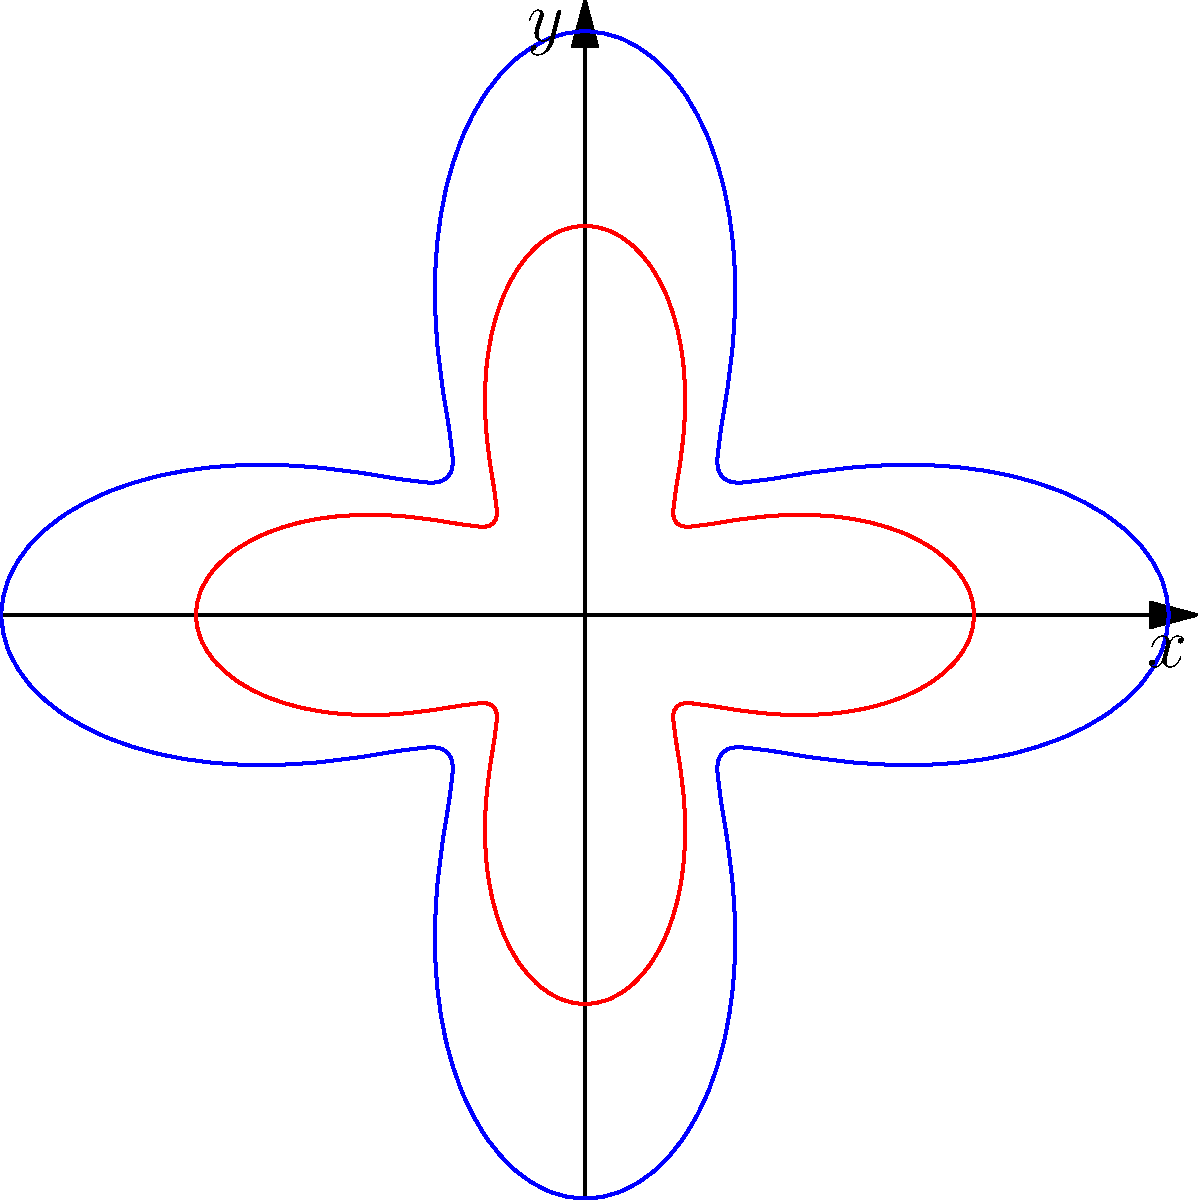The polar curve $r = 2 + \cos(4\theta)$ represents a simplified flower motif common in Vietnamese textiles. If this motif is scaled by a factor of 1.5, what is the new polar equation? To solve this problem, let's follow these steps:

1) The original polar equation is $r = 2 + \cos(4\theta)$.

2) When a polar curve is scaled by a factor $k$, the new equation is obtained by multiplying the right-hand side of the original equation by $k$.

3) In this case, the scaling factor is 1.5.

4) Therefore, we multiply the entire right-hand side of the original equation by 1.5:

   $r_{new} = 1.5(2 + \cos(4\theta))$

5) Simplifying:
   
   $r_{new} = 3 + 1.5\cos(4\theta)$

This new equation represents the scaled flower motif, where the petals are 1.5 times larger than the original, while maintaining the same symmetrical structure characteristic of Vietnamese textile patterns.
Answer: $r = 3 + 1.5\cos(4\theta)$ 